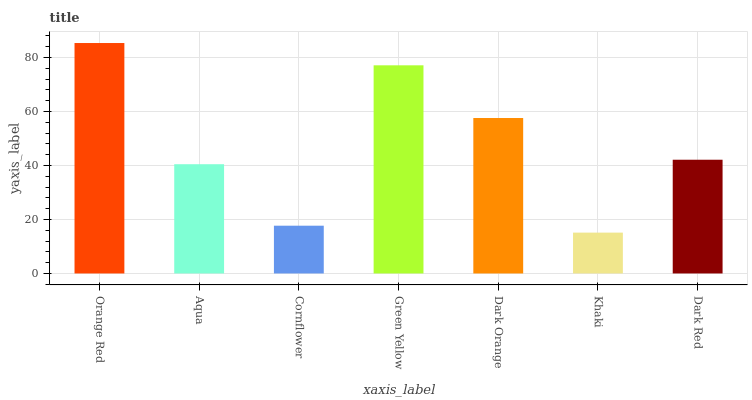Is Khaki the minimum?
Answer yes or no. Yes. Is Orange Red the maximum?
Answer yes or no. Yes. Is Aqua the minimum?
Answer yes or no. No. Is Aqua the maximum?
Answer yes or no. No. Is Orange Red greater than Aqua?
Answer yes or no. Yes. Is Aqua less than Orange Red?
Answer yes or no. Yes. Is Aqua greater than Orange Red?
Answer yes or no. No. Is Orange Red less than Aqua?
Answer yes or no. No. Is Dark Red the high median?
Answer yes or no. Yes. Is Dark Red the low median?
Answer yes or no. Yes. Is Dark Orange the high median?
Answer yes or no. No. Is Orange Red the low median?
Answer yes or no. No. 